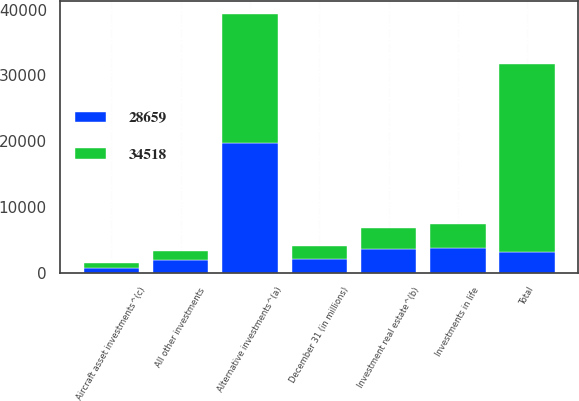<chart> <loc_0><loc_0><loc_500><loc_500><stacked_bar_chart><ecel><fcel>December 31 (in millions)<fcel>Alternative investments^(a)<fcel>Investment real estate^(b)<fcel>Aircraft asset investments^(c)<fcel>Investments in life<fcel>All other investments<fcel>Total<nl><fcel>28659<fcel>2014<fcel>19656<fcel>3612<fcel>651<fcel>3753<fcel>1874<fcel>3113<nl><fcel>34518<fcel>2013<fcel>19709<fcel>3113<fcel>763<fcel>3601<fcel>1388<fcel>28659<nl></chart> 